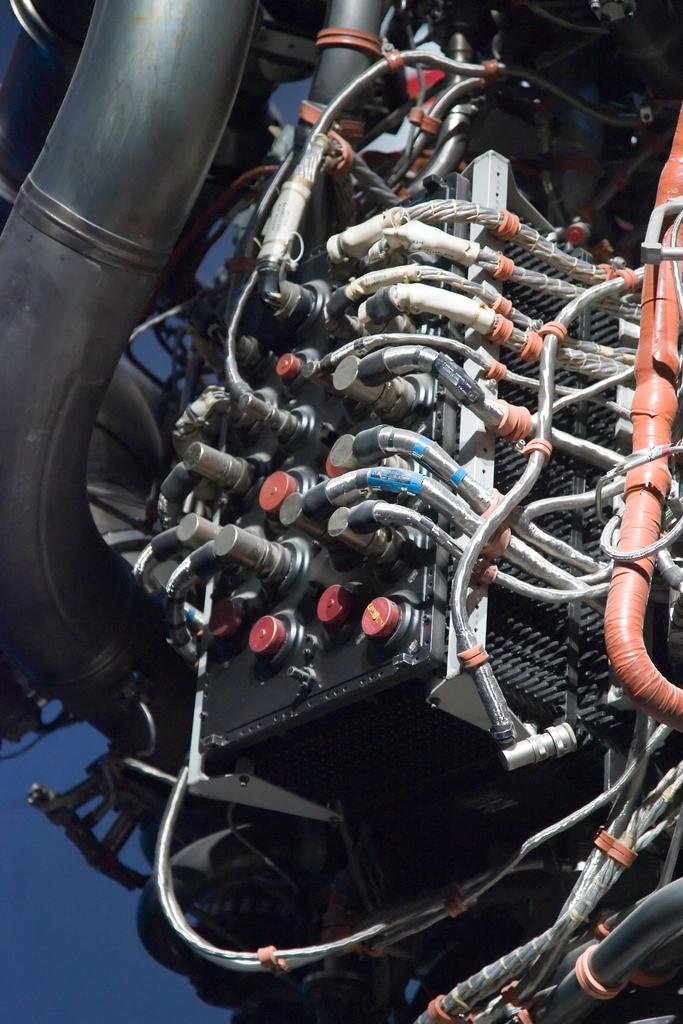What is the main subject of the image? The main subject of the image is an engine. What type of object does the engine belong to? The engine belongs to a vehicle. What type of insurance is required for the engine in the image? There is no information about insurance in the image, as it only shows an engine. 